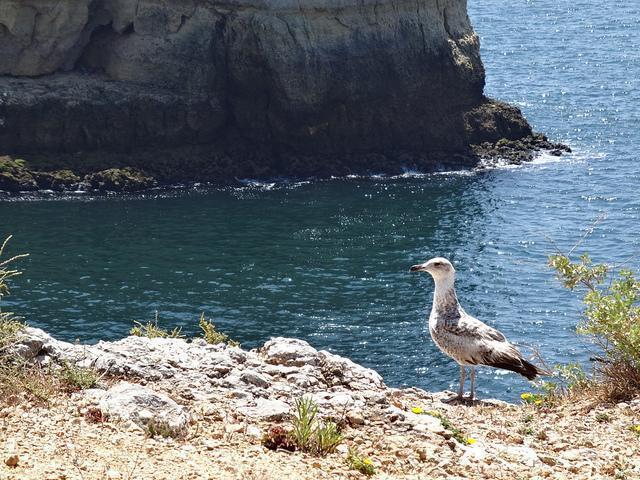How many people are wearing orange shirts?
Give a very brief answer. 0. 